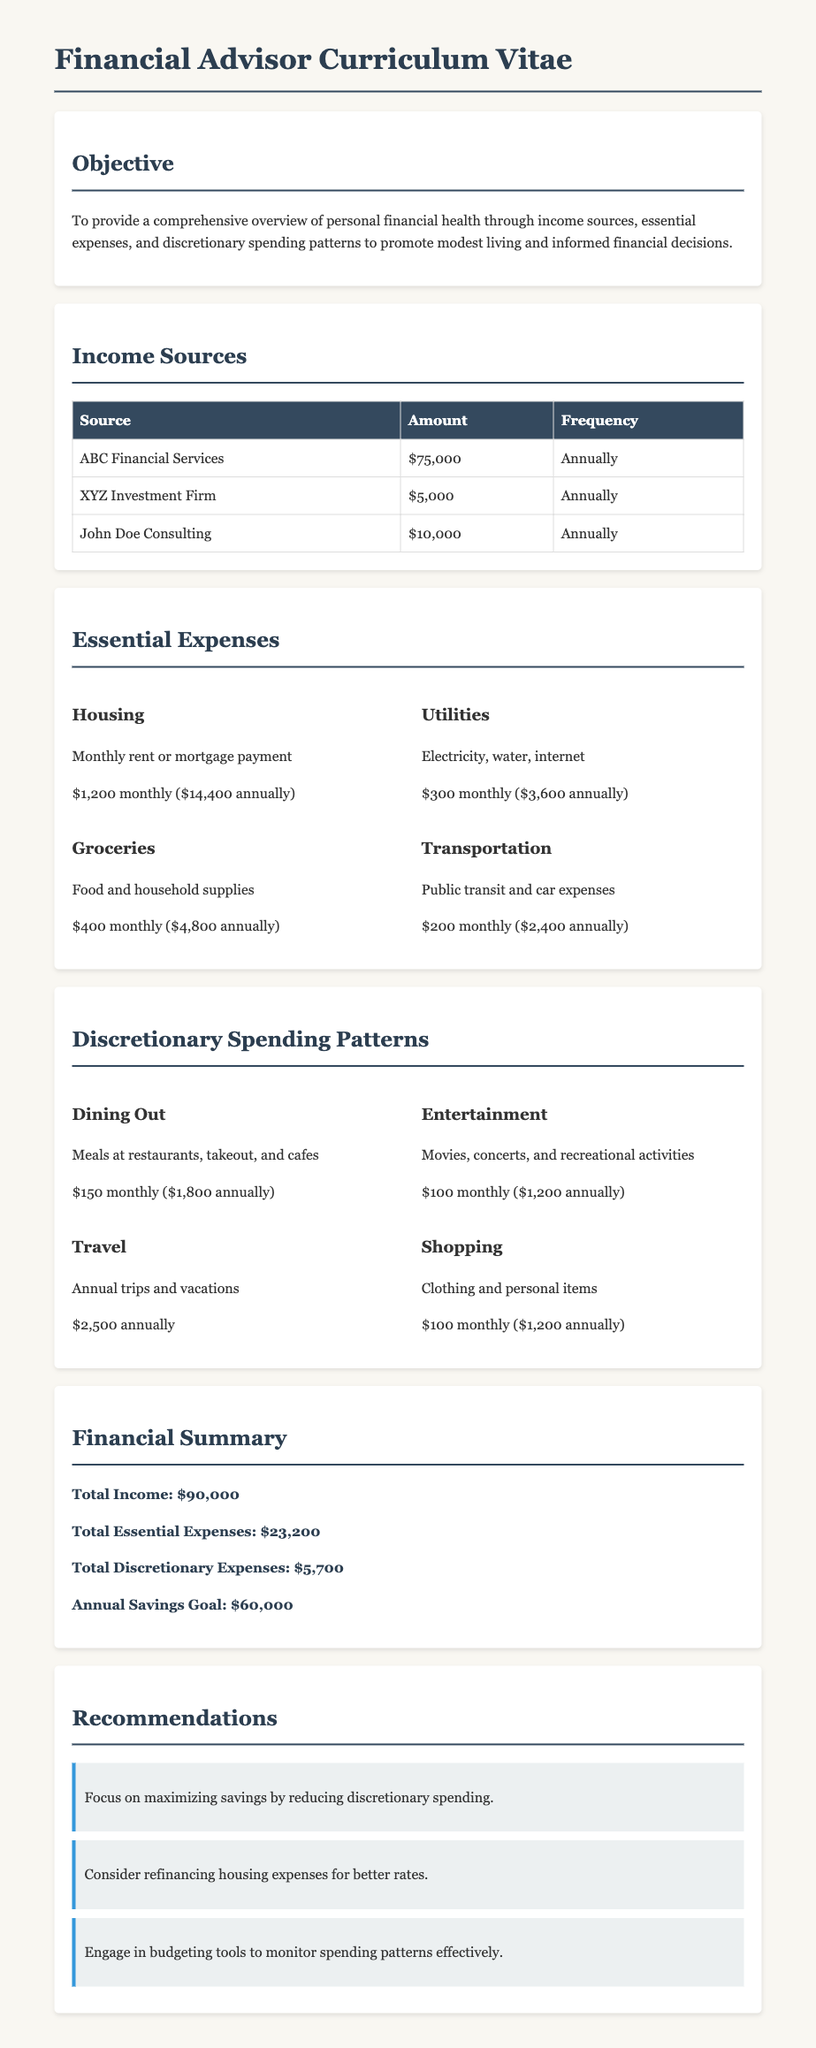What is the total income? The total income is the sum of all income sources listed in the document, which totals $75,000 + $5,000 + $10,000 = $90,000.
Answer: $90,000 What are monthly housing expenses? Monthly housing expenses are specifically mentioned as the rent or mortgage payment, which is stated as $1,200 monthly.
Answer: $1,200 What is the total amount for grocery expenses annually? Grocery expenses show $400 monthly, and when computed annually, it's $400 x 12 = $4,800.
Answer: $4,800 How much is spent on dining out monthly? The document specifies the spending on dining out is $150 each month.
Answer: $150 What is the recommendation regarding discretionary spending? The recommendation advises to focus on maximizing savings by reducing discretionary spending.
Answer: Reduce discretionary spending What is the annual savings goal according to the report? The annual savings goal is stated as a specific amount in the financial summary section, which is $60,000.
Answer: $60,000 What are the utilities expenses annually? Utilities expenses are detailed as $300 monthly, leading to an annual total of $300 x 12 = $3,600.
Answer: $3,600 What percentage of total income is spent on essential expenses? The total essential expenses are $23,200; thus, the percentage of total income is ($23,200 / $90,000) x 100 = approximately 25.78%.
Answer: Approximately 25.78% Which income source provides the least amount? Among the listed income sources, XYZ Investment Firm provides the least total amount of $5,000.
Answer: $5,000 